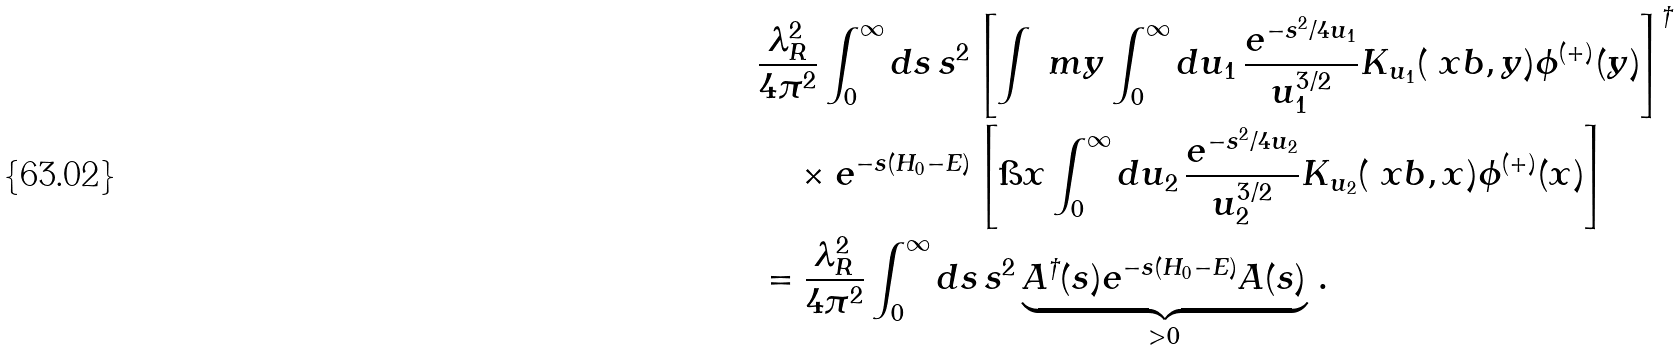<formula> <loc_0><loc_0><loc_500><loc_500>& \frac { \lambda _ { R } ^ { 2 } } { 4 \pi ^ { 2 } } \int ^ { \infty } _ { 0 } d s \, s ^ { 2 } \left [ \int \ m y \int ^ { \infty } _ { 0 } d u _ { 1 } \, \frac { e ^ { - s ^ { 2 } / 4 u _ { 1 } } } { u _ { 1 } ^ { 3 / 2 } } K _ { u _ { 1 } } ( \ x b , y ) \phi ^ { ( + ) } ( y ) \right ] ^ { \dag } \\ & \quad \times e ^ { - s ( H _ { 0 } - E ) } \left [ \i x \int ^ { \infty } _ { 0 } d u _ { 2 } \, \frac { e ^ { - s ^ { 2 } / 4 u _ { 2 } } } { u _ { 2 } ^ { 3 / 2 } } K _ { u _ { 2 } } ( \ x b , x ) \phi ^ { ( + ) } ( x ) \right ] \\ & = \frac { \lambda _ { R } ^ { 2 } } { 4 \pi ^ { 2 } } \int ^ { \infty } _ { 0 } d s \, s ^ { 2 } \underbrace { A ^ { \dag } ( s ) e ^ { - s ( H _ { 0 } - E ) } A ( s ) } _ { > 0 } \, .</formula> 